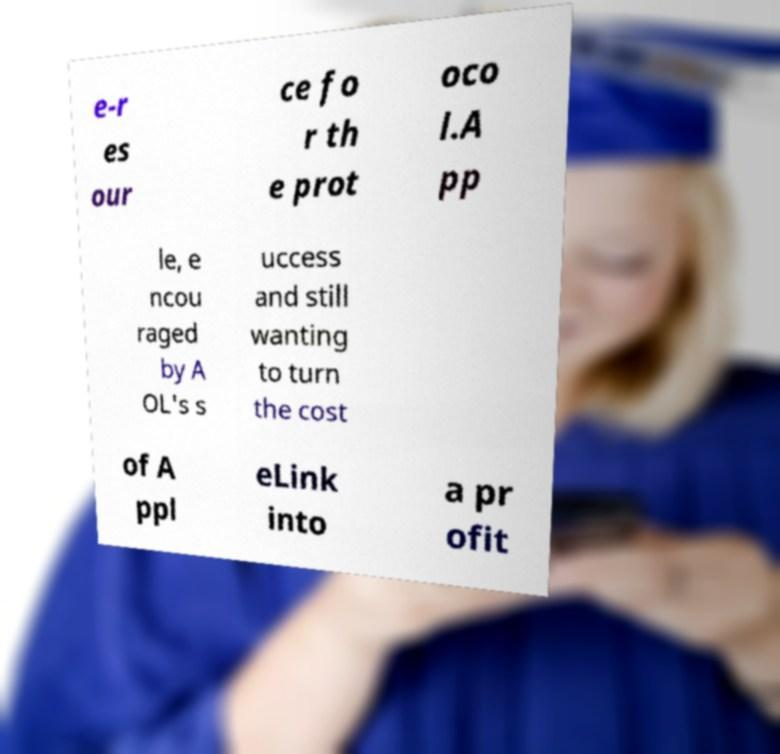For documentation purposes, I need the text within this image transcribed. Could you provide that? e-r es our ce fo r th e prot oco l.A pp le, e ncou raged by A OL's s uccess and still wanting to turn the cost of A ppl eLink into a pr ofit 